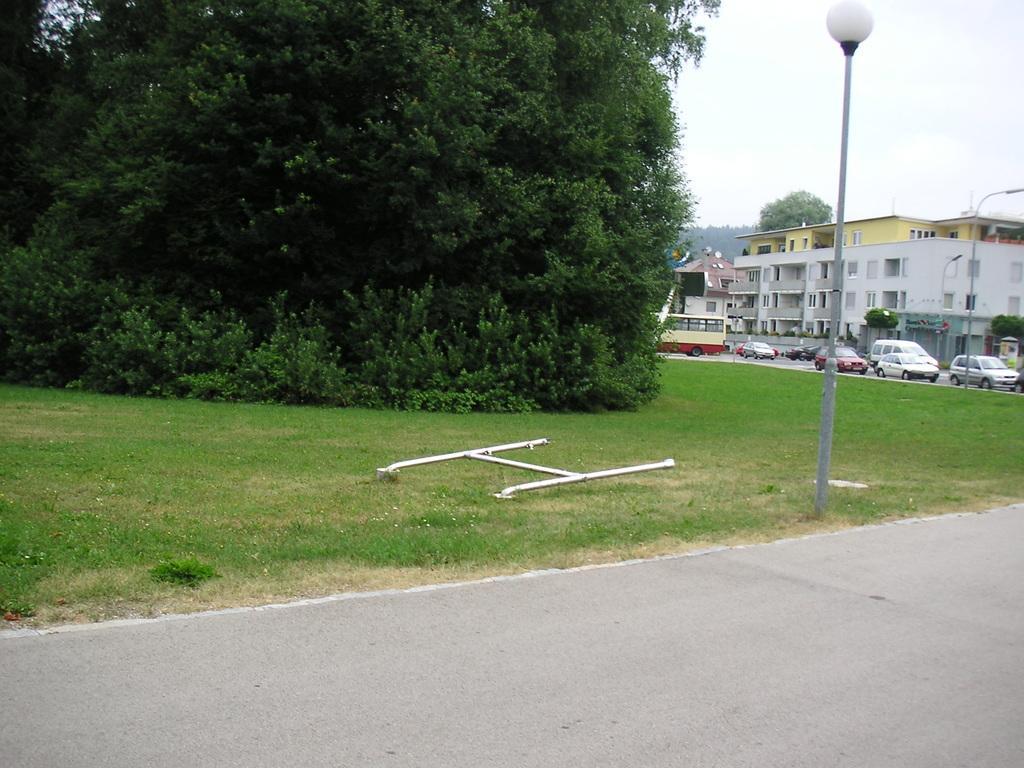In one or two sentences, can you explain what this image depicts? In the center of the image we can see trees, buildings, bus, cars, electric light poles are there. At the top of the image sky is there. At the bottom of the image road is there. In the middle of the image some grass is there. 